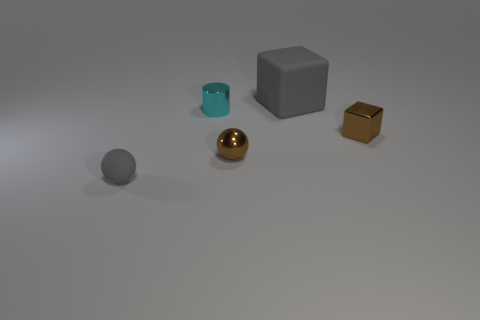What is the color of the cube that is the same material as the gray ball?
Your answer should be very brief. Gray. Are there any other things that are the same size as the brown metal ball?
Your response must be concise. Yes. Is the color of the ball to the left of the metal cylinder the same as the cube in front of the large matte cube?
Make the answer very short. No. Is the number of metal spheres that are left of the tiny brown metal sphere greater than the number of small brown shiny objects that are to the right of the tiny cyan thing?
Make the answer very short. No. There is another shiny object that is the same shape as the big gray thing; what color is it?
Offer a very short reply. Brown. Is there anything else that is the same shape as the big rubber thing?
Offer a very short reply. Yes. Does the tiny cyan thing have the same shape as the gray thing that is to the left of the small metal cylinder?
Your response must be concise. No. What number of other objects are the same material as the cylinder?
Your answer should be compact. 2. There is a matte sphere; does it have the same color as the rubber thing that is behind the small gray thing?
Your response must be concise. Yes. There is a tiny brown object that is right of the gray cube; what is it made of?
Offer a very short reply. Metal. 